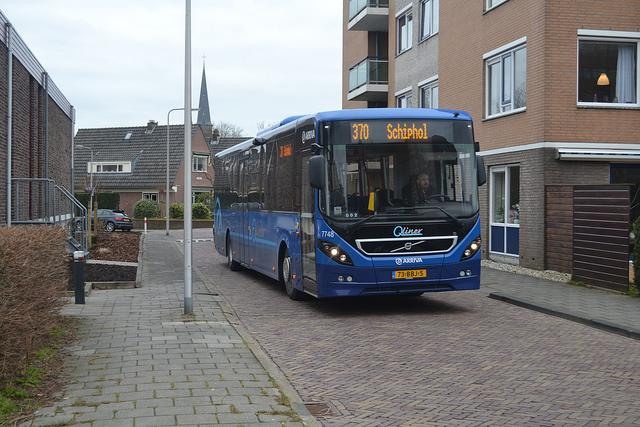What do people do inside the building with the spire on it? pray 